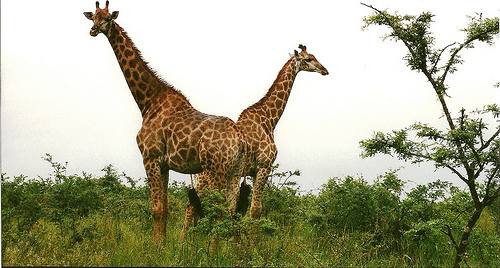<image>
Is the giraffe to the left of the grass? No. The giraffe is not to the left of the grass. From this viewpoint, they have a different horizontal relationship. 